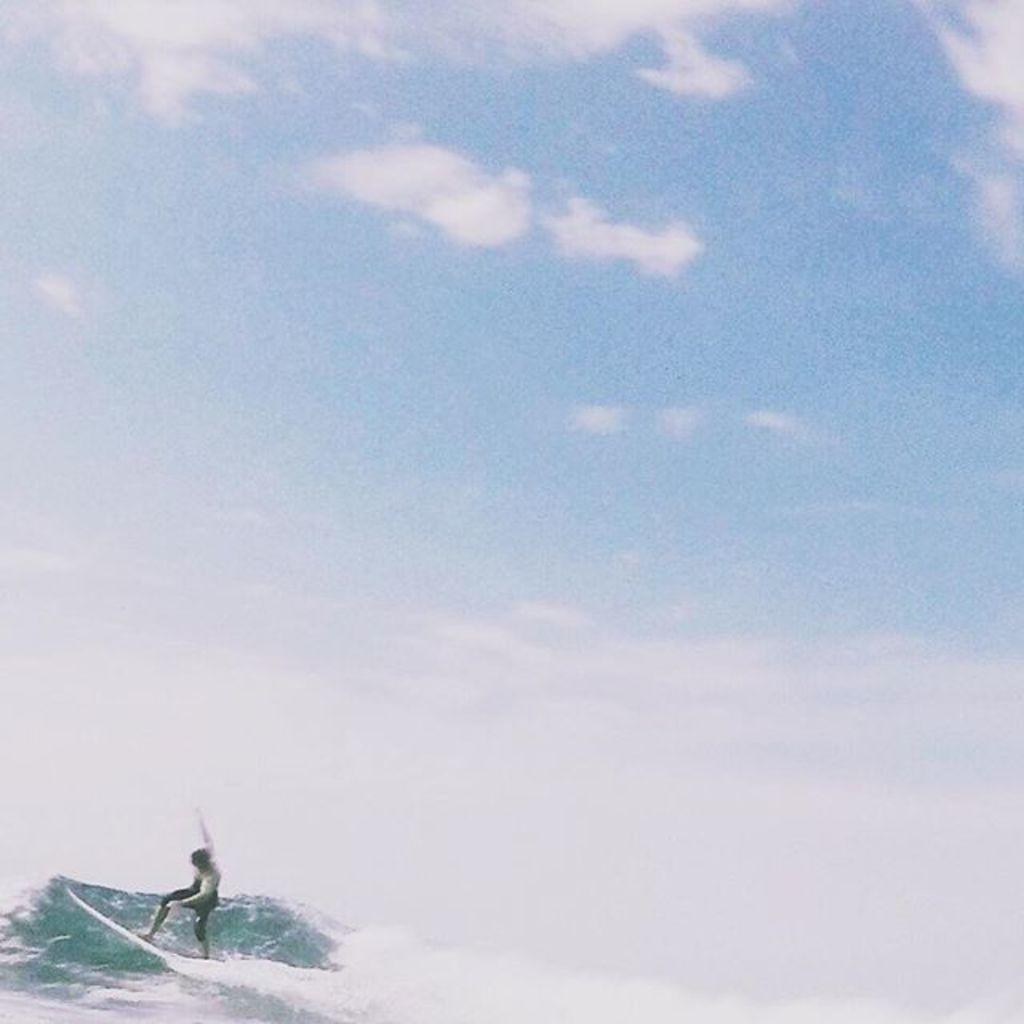Who is the main subject in the image? There is a boy in the image. What is the boy doing in the image? The boy is surfing on a boat. Where is the boat located in the image? The boat is in the sea water. What can be seen above the boat in the image? There is sky visible in the image, and clouds are present in the sky. What is the cent's authority in the image? There is no cent or any reference to a cent in the image. 